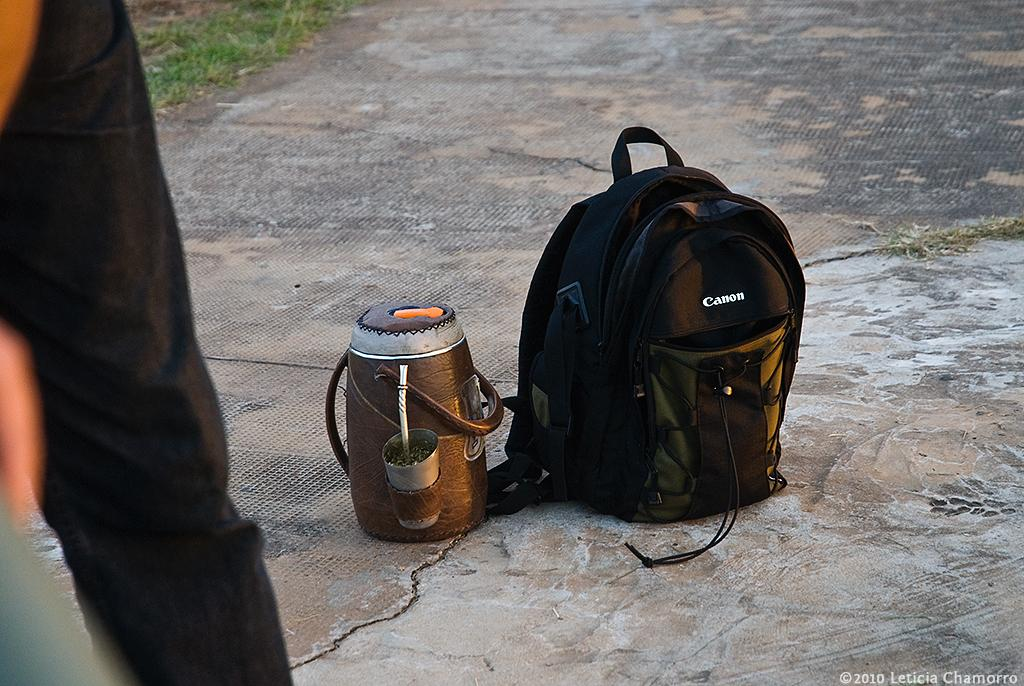<image>
Present a compact description of the photo's key features. A black Canon backpack sits on the ground. 